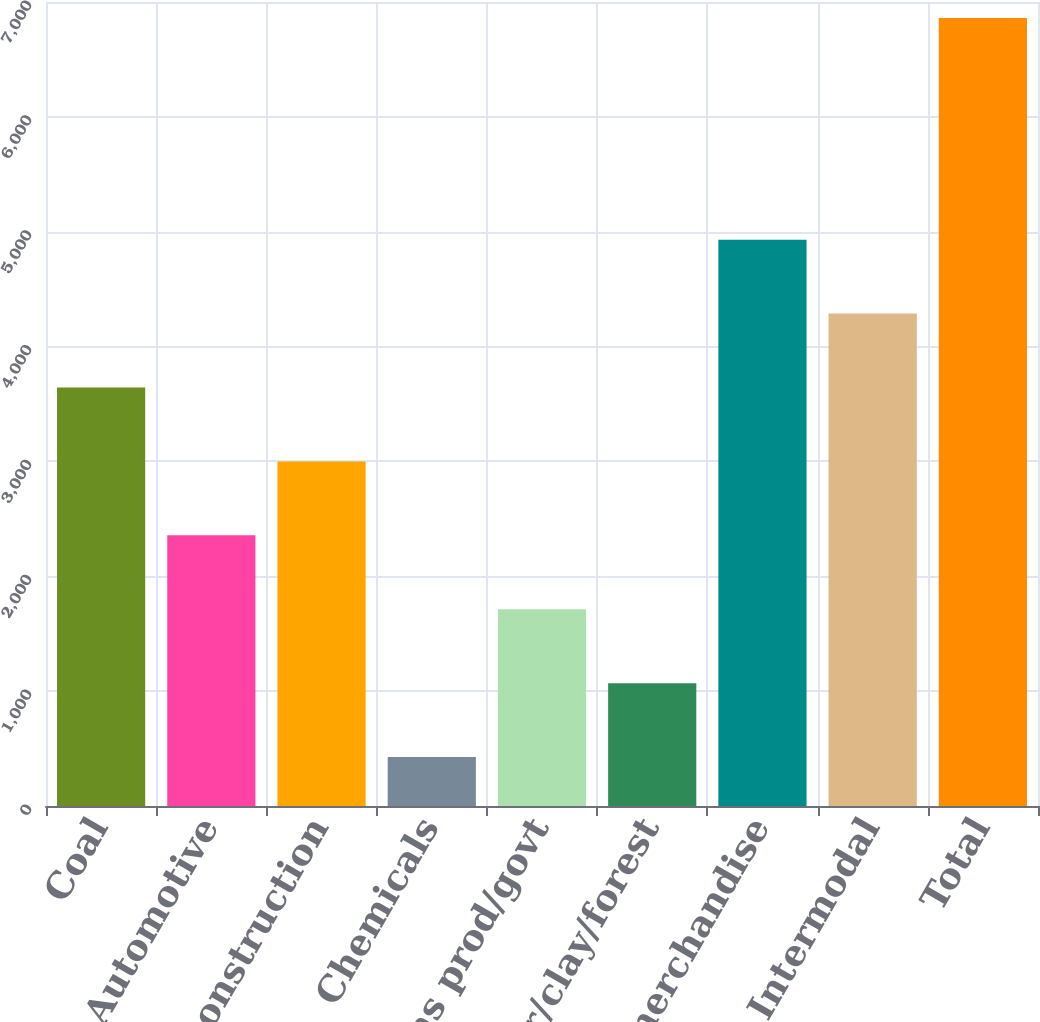Convert chart. <chart><loc_0><loc_0><loc_500><loc_500><bar_chart><fcel>Coal<fcel>Automotive<fcel>Metals/construction<fcel>Chemicals<fcel>Agr/cons prod/govt<fcel>Paper/clay/forest<fcel>General merchandise<fcel>Intermodal<fcel>Total<nl><fcel>3643.45<fcel>2356.35<fcel>2999.9<fcel>425.7<fcel>1712.8<fcel>1069.25<fcel>4930.55<fcel>4287<fcel>6861.2<nl></chart> 